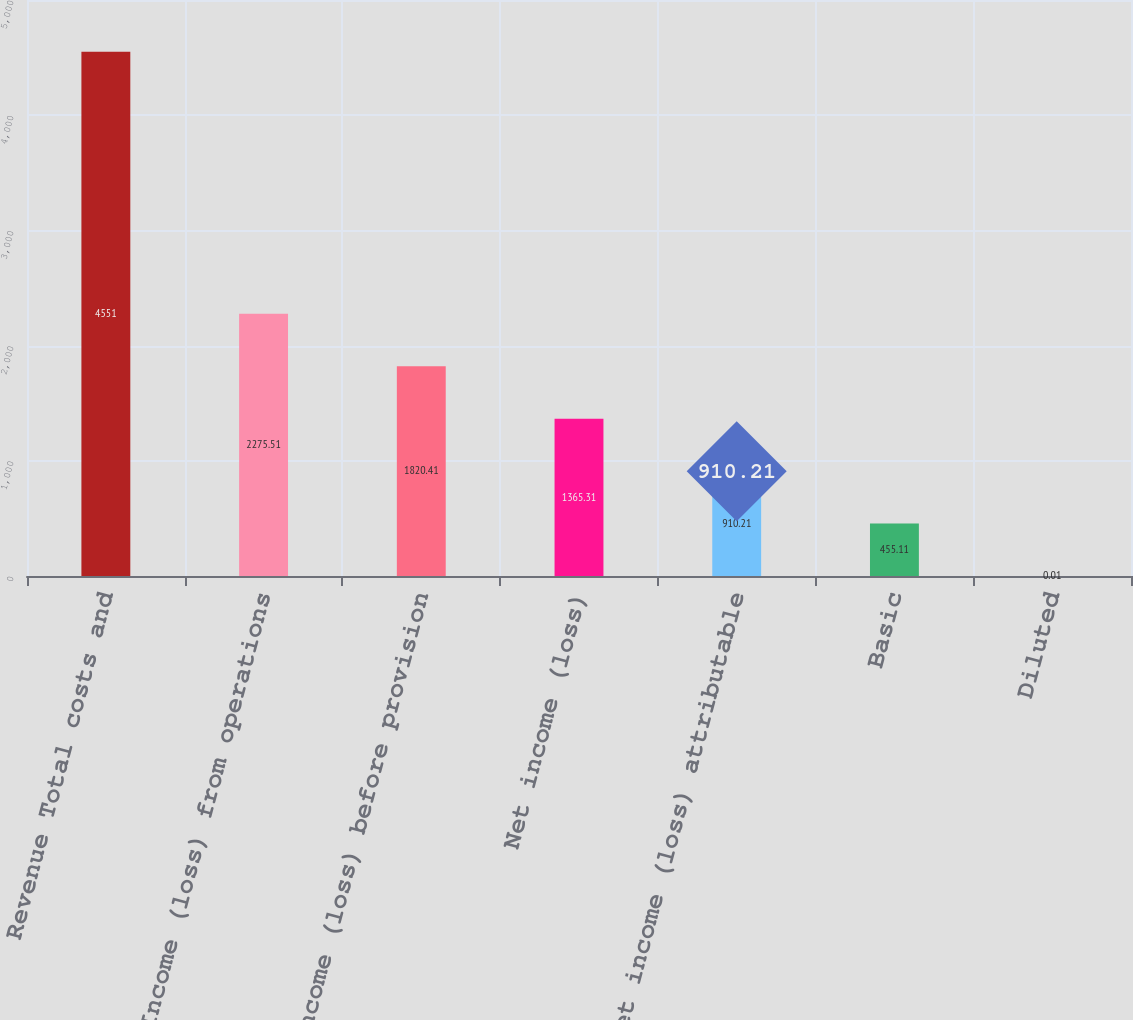<chart> <loc_0><loc_0><loc_500><loc_500><bar_chart><fcel>Revenue Total costs and<fcel>Income (loss) from operations<fcel>Income (loss) before provision<fcel>Net income (loss)<fcel>Net income (loss) attributable<fcel>Basic<fcel>Diluted<nl><fcel>4551<fcel>2275.51<fcel>1820.41<fcel>1365.31<fcel>910.21<fcel>455.11<fcel>0.01<nl></chart> 